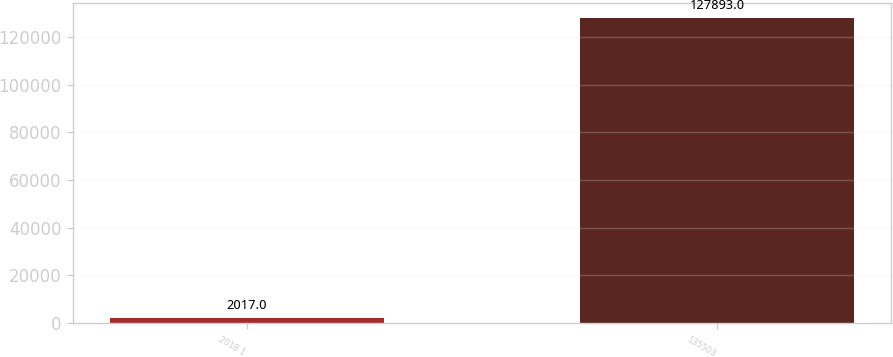<chart> <loc_0><loc_0><loc_500><loc_500><bar_chart><fcel>2018 1<fcel>135503<nl><fcel>2017<fcel>127893<nl></chart> 